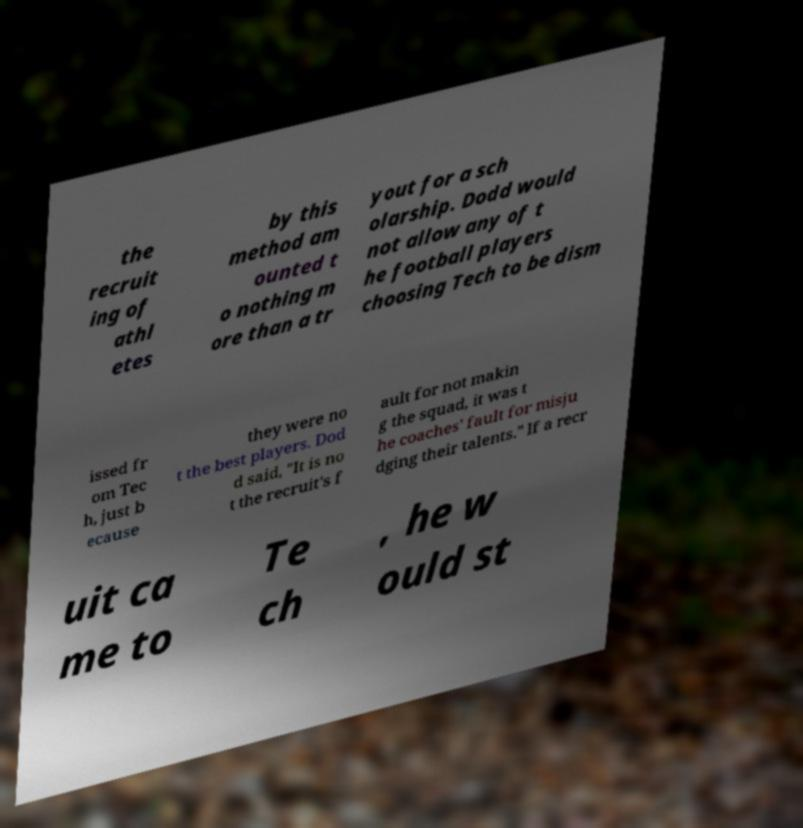For documentation purposes, I need the text within this image transcribed. Could you provide that? the recruit ing of athl etes by this method am ounted t o nothing m ore than a tr yout for a sch olarship. Dodd would not allow any of t he football players choosing Tech to be dism issed fr om Tec h, just b ecause they were no t the best players. Dod d said, "It is no t the recruit's f ault for not makin g the squad, it was t he coaches' fault for misju dging their talents." If a recr uit ca me to Te ch , he w ould st 